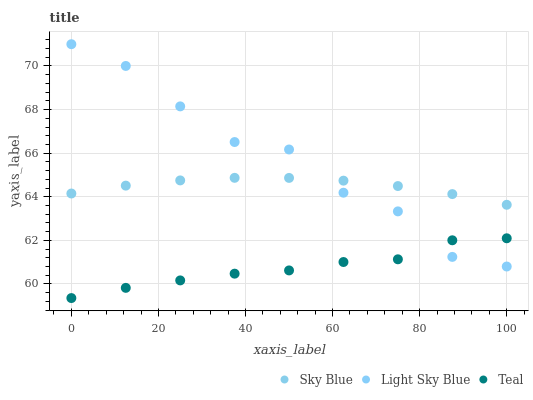Does Teal have the minimum area under the curve?
Answer yes or no. Yes. Does Light Sky Blue have the maximum area under the curve?
Answer yes or no. Yes. Does Light Sky Blue have the minimum area under the curve?
Answer yes or no. No. Does Teal have the maximum area under the curve?
Answer yes or no. No. Is Sky Blue the smoothest?
Answer yes or no. Yes. Is Light Sky Blue the roughest?
Answer yes or no. Yes. Is Teal the smoothest?
Answer yes or no. No. Is Teal the roughest?
Answer yes or no. No. Does Teal have the lowest value?
Answer yes or no. Yes. Does Light Sky Blue have the lowest value?
Answer yes or no. No. Does Light Sky Blue have the highest value?
Answer yes or no. Yes. Does Teal have the highest value?
Answer yes or no. No. Is Teal less than Sky Blue?
Answer yes or no. Yes. Is Sky Blue greater than Teal?
Answer yes or no. Yes. Does Teal intersect Light Sky Blue?
Answer yes or no. Yes. Is Teal less than Light Sky Blue?
Answer yes or no. No. Is Teal greater than Light Sky Blue?
Answer yes or no. No. Does Teal intersect Sky Blue?
Answer yes or no. No. 